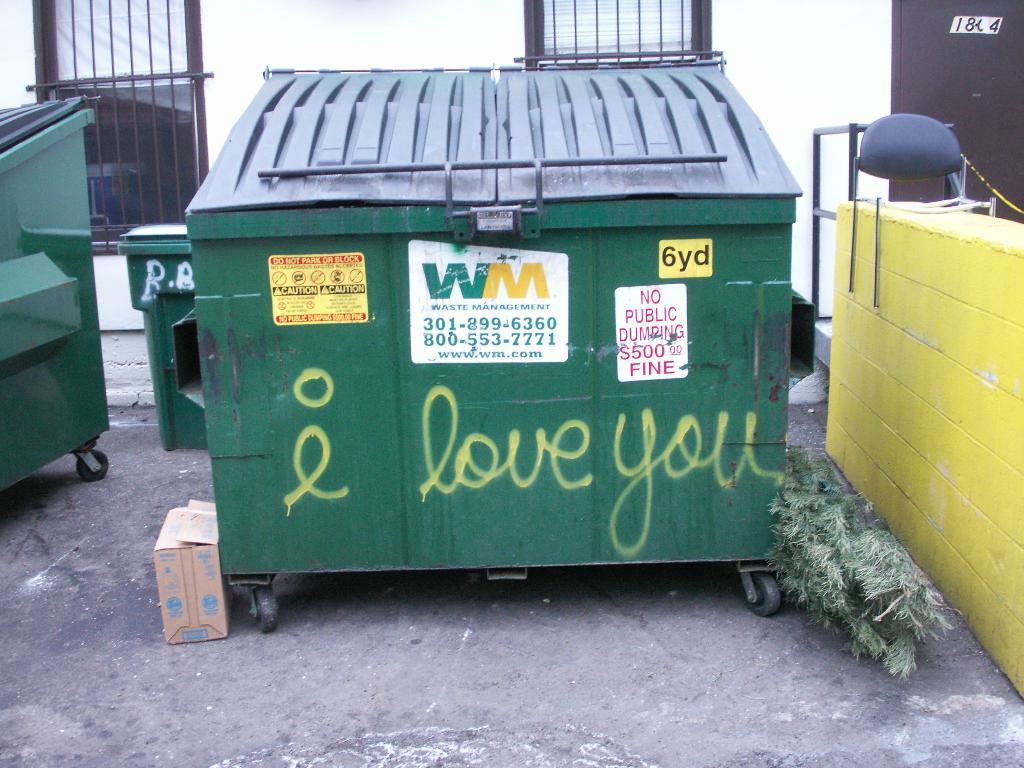<image>
Create a compact narrative representing the image presented. An outside large green dumpster from waste management 